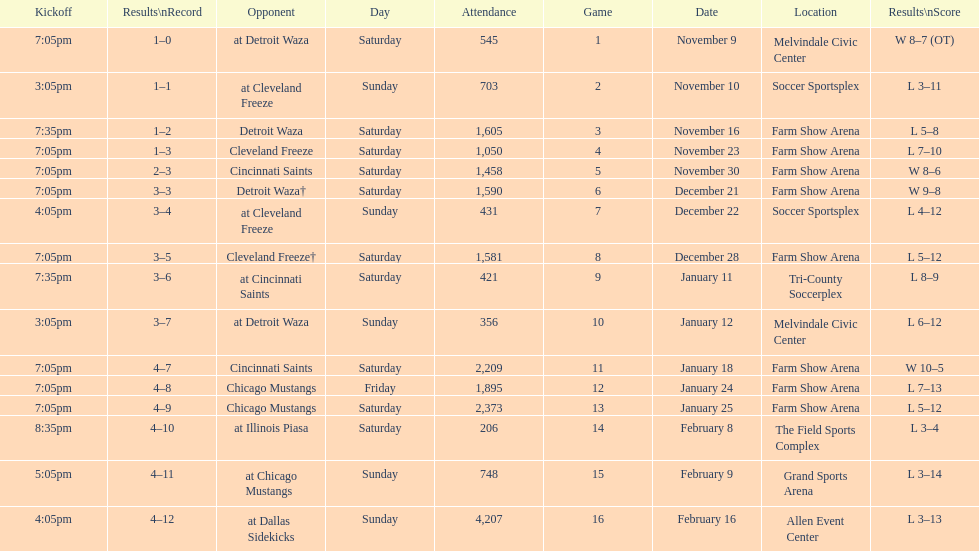What is the date of the game after december 22? December 28. Help me parse the entirety of this table. {'header': ['Kickoff', 'Results\\nRecord', 'Opponent', 'Day', 'Attendance', 'Game', 'Date', 'Location', 'Results\\nScore'], 'rows': [['7:05pm', '1–0', 'at Detroit Waza', 'Saturday', '545', '1', 'November 9', 'Melvindale Civic Center', 'W 8–7 (OT)'], ['3:05pm', '1–1', 'at Cleveland Freeze', 'Sunday', '703', '2', 'November 10', 'Soccer Sportsplex', 'L 3–11'], ['7:35pm', '1–2', 'Detroit Waza', 'Saturday', '1,605', '3', 'November 16', 'Farm Show Arena', 'L 5–8'], ['7:05pm', '1–3', 'Cleveland Freeze', 'Saturday', '1,050', '4', 'November 23', 'Farm Show Arena', 'L 7–10'], ['7:05pm', '2–3', 'Cincinnati Saints', 'Saturday', '1,458', '5', 'November 30', 'Farm Show Arena', 'W 8–6'], ['7:05pm', '3–3', 'Detroit Waza†', 'Saturday', '1,590', '6', 'December 21', 'Farm Show Arena', 'W 9–8'], ['4:05pm', '3–4', 'at Cleveland Freeze', 'Sunday', '431', '7', 'December 22', 'Soccer Sportsplex', 'L 4–12'], ['7:05pm', '3–5', 'Cleveland Freeze†', 'Saturday', '1,581', '8', 'December 28', 'Farm Show Arena', 'L 5–12'], ['7:35pm', '3–6', 'at Cincinnati Saints', 'Saturday', '421', '9', 'January 11', 'Tri-County Soccerplex', 'L 8–9'], ['3:05pm', '3–7', 'at Detroit Waza', 'Sunday', '356', '10', 'January 12', 'Melvindale Civic Center', 'L 6–12'], ['7:05pm', '4–7', 'Cincinnati Saints', 'Saturday', '2,209', '11', 'January 18', 'Farm Show Arena', 'W 10–5'], ['7:05pm', '4–8', 'Chicago Mustangs', 'Friday', '1,895', '12', 'January 24', 'Farm Show Arena', 'L 7–13'], ['7:05pm', '4–9', 'Chicago Mustangs', 'Saturday', '2,373', '13', 'January 25', 'Farm Show Arena', 'L 5–12'], ['8:35pm', '4–10', 'at Illinois Piasa', 'Saturday', '206', '14', 'February 8', 'The Field Sports Complex', 'L 3–4'], ['5:05pm', '4–11', 'at Chicago Mustangs', 'Sunday', '748', '15', 'February 9', 'Grand Sports Arena', 'L 3–14'], ['4:05pm', '4–12', 'at Dallas Sidekicks', 'Sunday', '4,207', '16', 'February 16', 'Allen Event Center', 'L 3–13']]} 